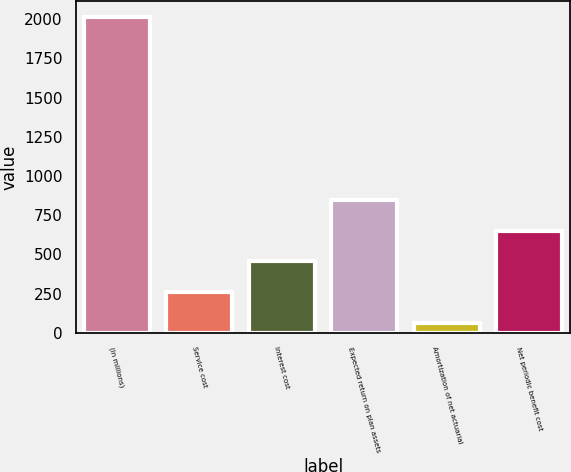Convert chart. <chart><loc_0><loc_0><loc_500><loc_500><bar_chart><fcel>(in millions)<fcel>Service cost<fcel>Interest cost<fcel>Expected return on plan assets<fcel>Amortization of net actuarial<fcel>Net periodic benefit cost<nl><fcel>2015<fcel>260<fcel>455<fcel>845<fcel>65<fcel>650<nl></chart> 